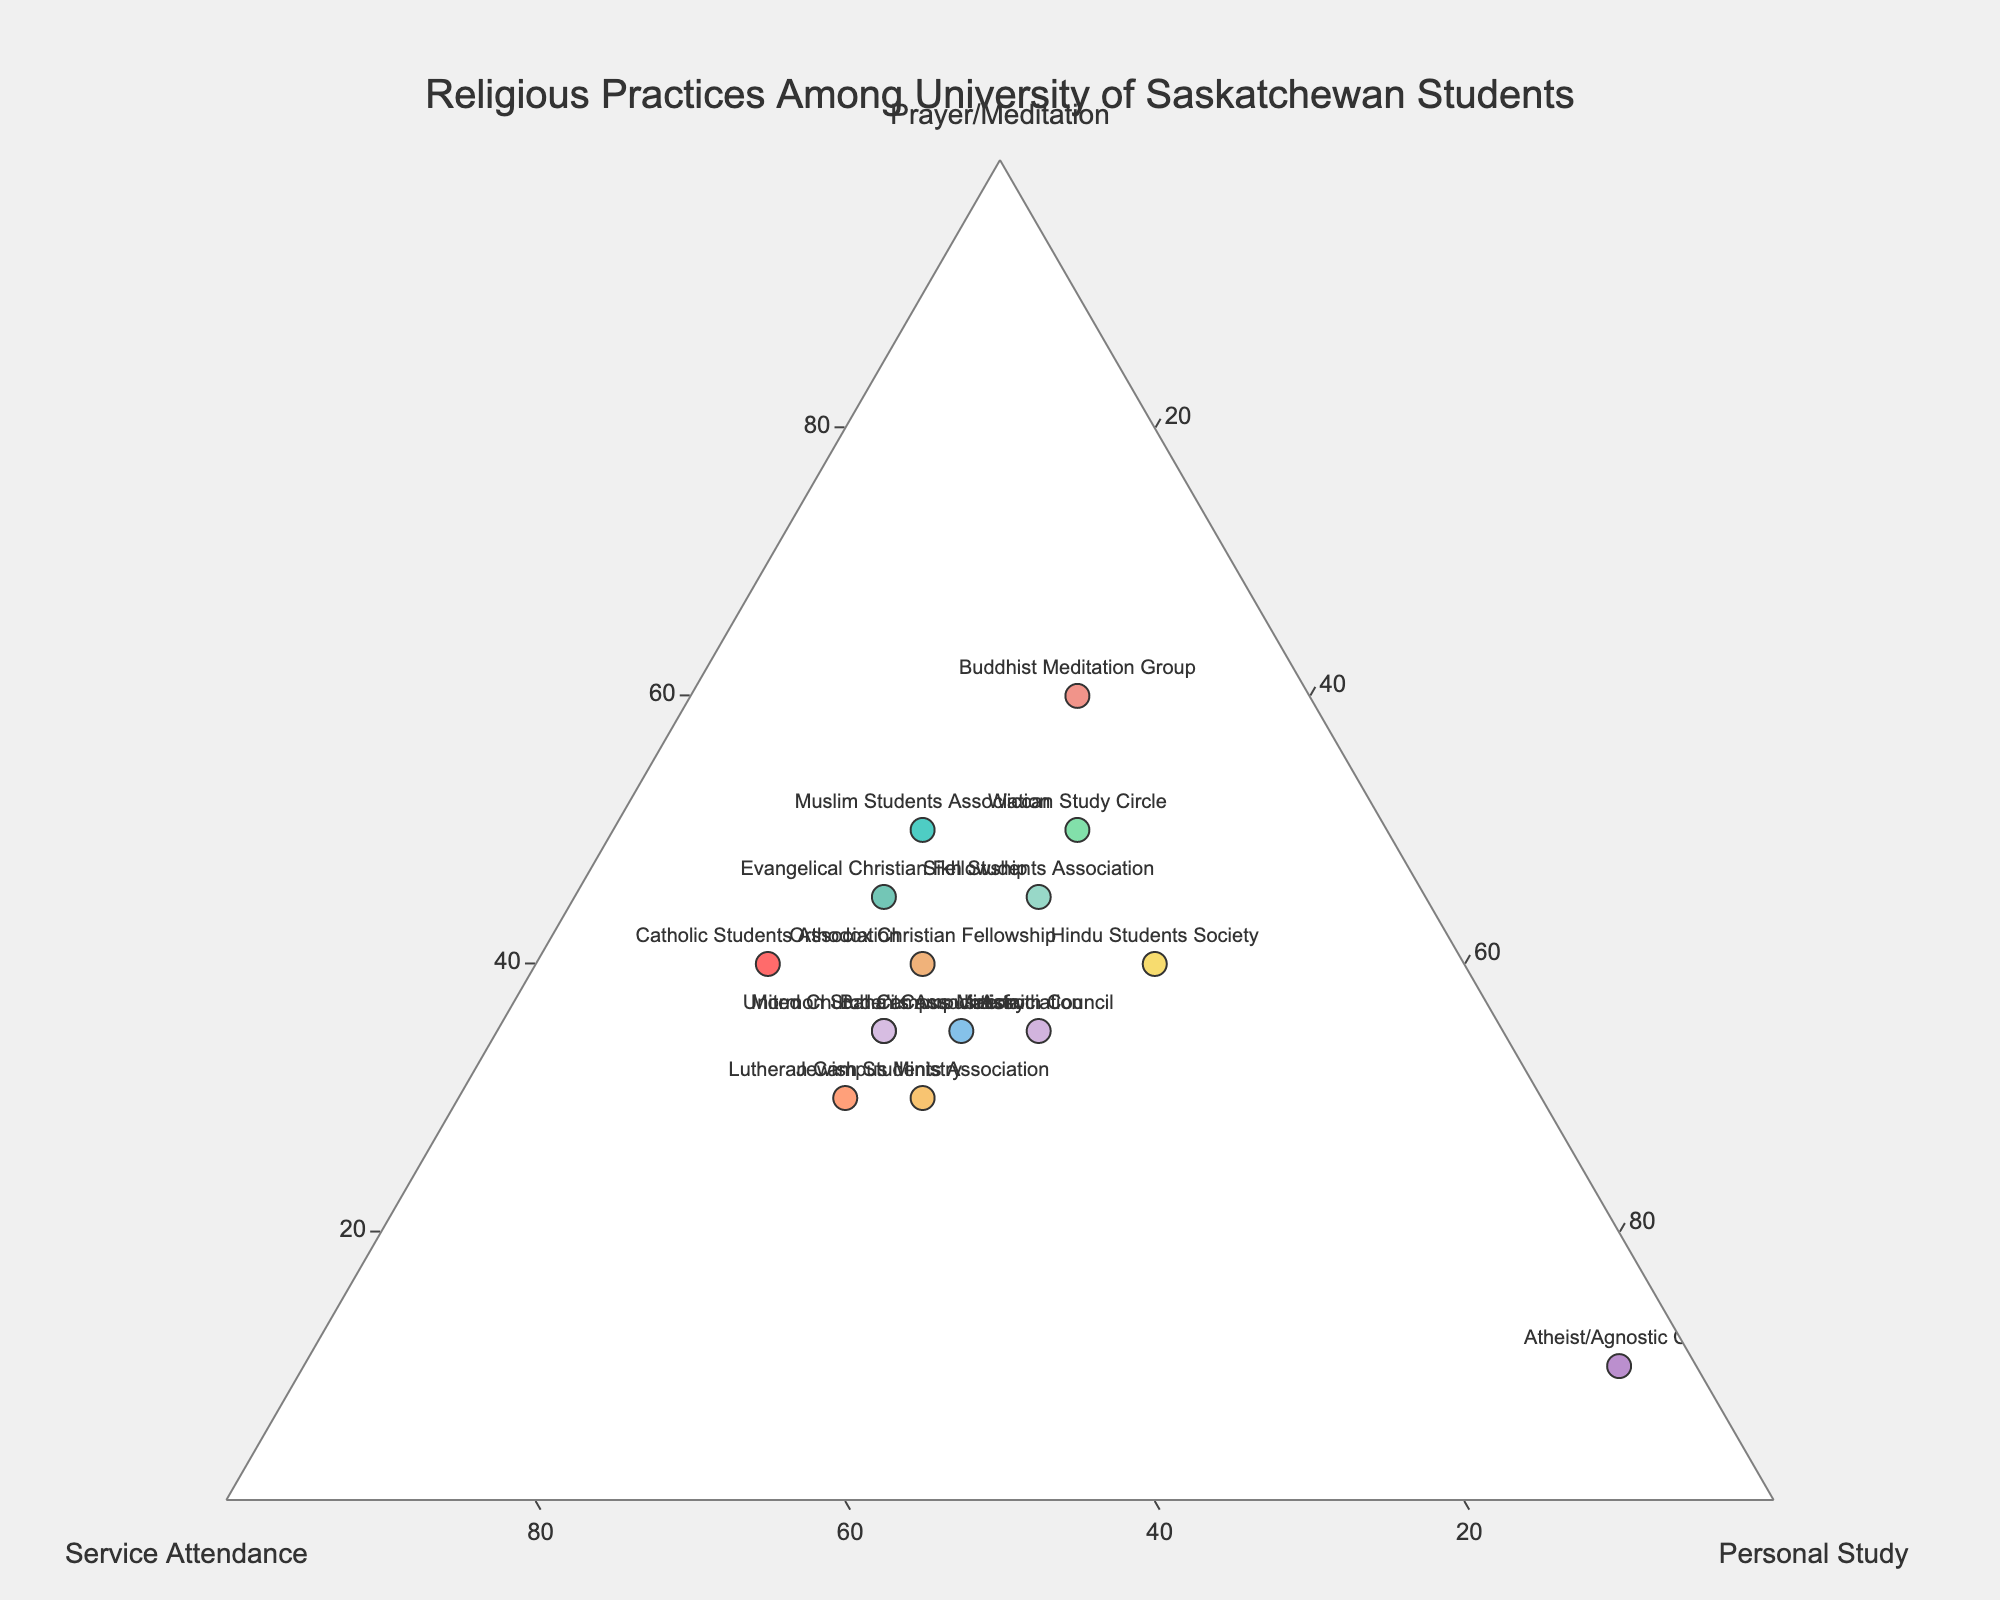What is the title of the ternary plot? The title is centered at the top of the plot and reads: "Religious Practices Among University of Saskatchewan Students".
Answer: Religious Practices Among University of Saskatchewan Students How many religious groups are plotted on the ternary plot? Count the number of distinct text labels next to the markers on the ternary plot to determine the number of religious groups represented.
Answer: 15 Which group reports the highest level of prayer/meditation? Look for the marker that is closest to the top corner of the triangle labeled “Prayer/Meditation (100%)”. This position represents the group engaging most in prayer/meditation.
Answer: Buddhist Meditation Group Which group has the highest percentage in personal study? Find the marker that is closest to the bottom left corner of the triangle labeled “Personal Study (100%)”. This position indicates the highest level of personal study.
Answer: Atheist/Agnostic Club Which group has equal percentages in prayer/meditation and service attendance? Identify the marker where the percentages of prayer/meditation and service attendance are equal by looking at groups whose markers are positioned along the bisector line between these two axes.
Answer: Catholic Students Association What is the sum of the percentages for personal study from the Sikh Students Association, Hindu Students Society, and Jewish Students Association? Locate each group's marker, look at the percentage for personal study, and sum them up: 30 (Sikh) + 40 (Hindu) + 30 (Jewish).
Answer: 100 Which group shows a balance among prayer/meditation, service attendance, and personal study? Look for a marker that is close to the center of the triangular plot where the percentages for prayer/meditation, service attendance, and personal study are approximately equal.
Answer: Interfaith Council Compare the focus on prayer/meditation between the Catholic Students Association and the Evangelical Christian Fellowship. Which has a higher percentage? Locate the markers for both groups and compare their positions along the “Prayer/Meditation” axis. The group closer to the “Prayer/Meditation (100%)” corner has the higher percentage.
Answer: Evangelical Christian Fellowship Which group attends religious services the least? Find the marker closest to the left side of the triangle where “Service Attendance (0%)” is indicated. This marks the group with the least attendance at religious services.
Answer: Atheist/Agnostic Club 